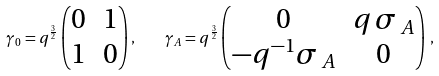<formula> <loc_0><loc_0><loc_500><loc_500>\gamma _ { 0 } = q ^ { \frac { 3 } { 2 } } \begin{pmatrix} 0 & 1 \\ 1 & 0 \end{pmatrix} , \quad \gamma _ { A } = q ^ { \frac { 3 } { 2 } } \begin{pmatrix} 0 & q \, \sigma \, _ { A } \\ - q ^ { - 1 } \sigma \, _ { A } & 0 \end{pmatrix} \, ,</formula> 